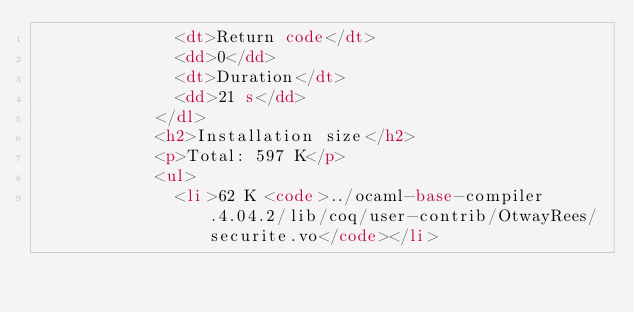<code> <loc_0><loc_0><loc_500><loc_500><_HTML_>              <dt>Return code</dt>
              <dd>0</dd>
              <dt>Duration</dt>
              <dd>21 s</dd>
            </dl>
            <h2>Installation size</h2>
            <p>Total: 597 K</p>
            <ul>
              <li>62 K <code>../ocaml-base-compiler.4.04.2/lib/coq/user-contrib/OtwayRees/securite.vo</code></li></code> 